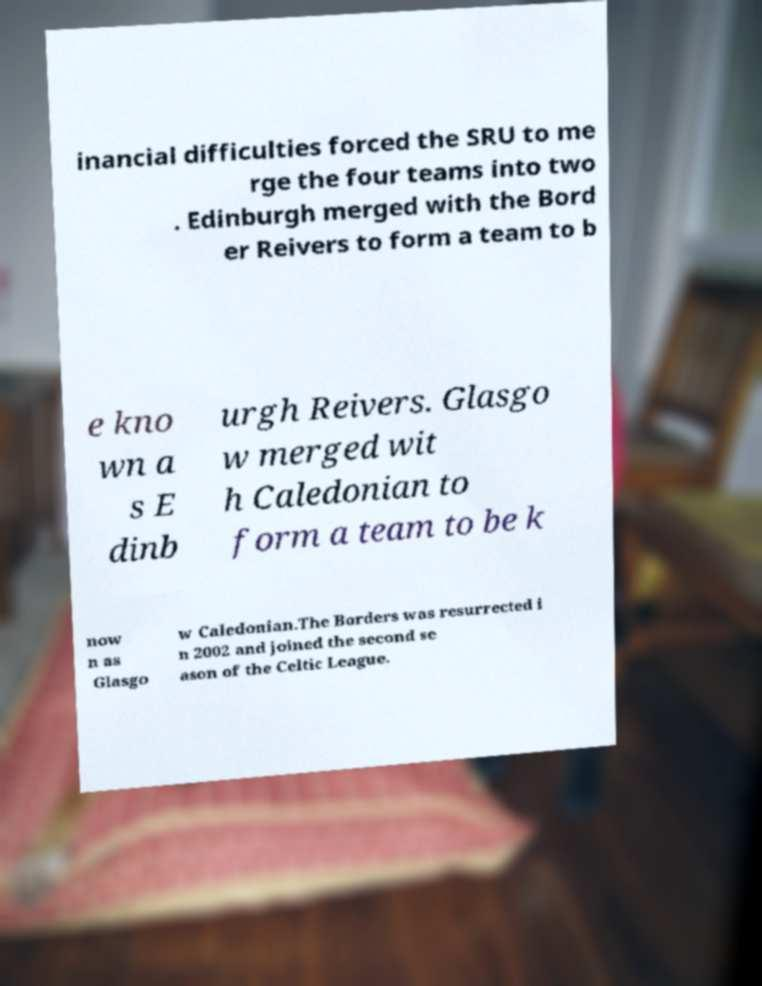What messages or text are displayed in this image? I need them in a readable, typed format. inancial difficulties forced the SRU to me rge the four teams into two . Edinburgh merged with the Bord er Reivers to form a team to b e kno wn a s E dinb urgh Reivers. Glasgo w merged wit h Caledonian to form a team to be k now n as Glasgo w Caledonian.The Borders was resurrected i n 2002 and joined the second se ason of the Celtic League. 